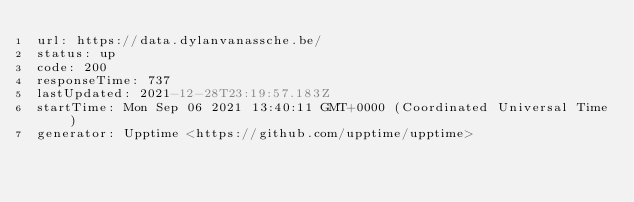Convert code to text. <code><loc_0><loc_0><loc_500><loc_500><_YAML_>url: https://data.dylanvanassche.be/
status: up
code: 200
responseTime: 737
lastUpdated: 2021-12-28T23:19:57.183Z
startTime: Mon Sep 06 2021 13:40:11 GMT+0000 (Coordinated Universal Time)
generator: Upptime <https://github.com/upptime/upptime>
</code> 